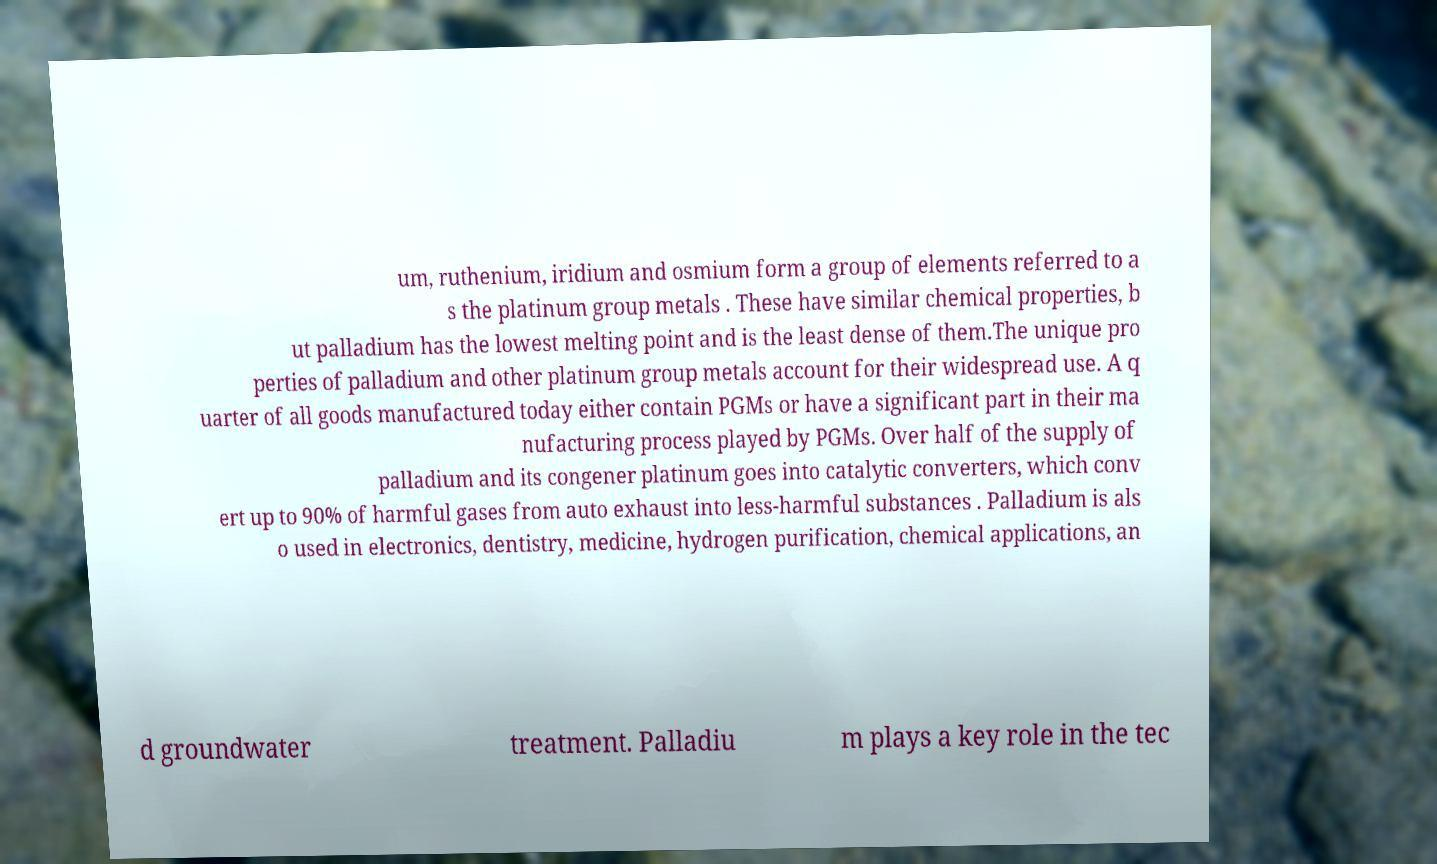Could you assist in decoding the text presented in this image and type it out clearly? um, ruthenium, iridium and osmium form a group of elements referred to a s the platinum group metals . These have similar chemical properties, b ut palladium has the lowest melting point and is the least dense of them.The unique pro perties of palladium and other platinum group metals account for their widespread use. A q uarter of all goods manufactured today either contain PGMs or have a significant part in their ma nufacturing process played by PGMs. Over half of the supply of palladium and its congener platinum goes into catalytic converters, which conv ert up to 90% of harmful gases from auto exhaust into less-harmful substances . Palladium is als o used in electronics, dentistry, medicine, hydrogen purification, chemical applications, an d groundwater treatment. Palladiu m plays a key role in the tec 